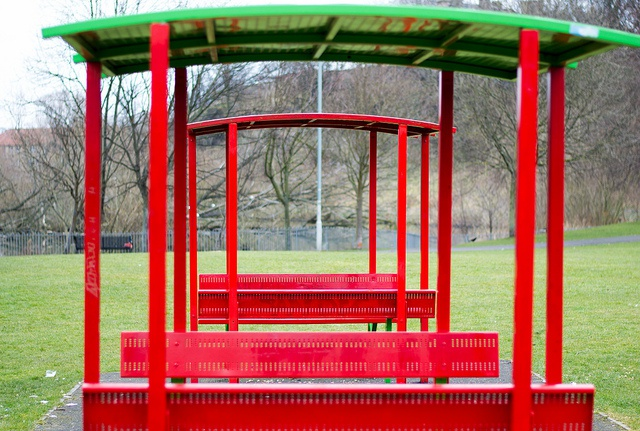Describe the objects in this image and their specific colors. I can see bench in white, brown, maroon, and pink tones, bench in white, red, and salmon tones, bench in white, red, brown, and salmon tones, and bench in white, gray, blue, and black tones in this image. 